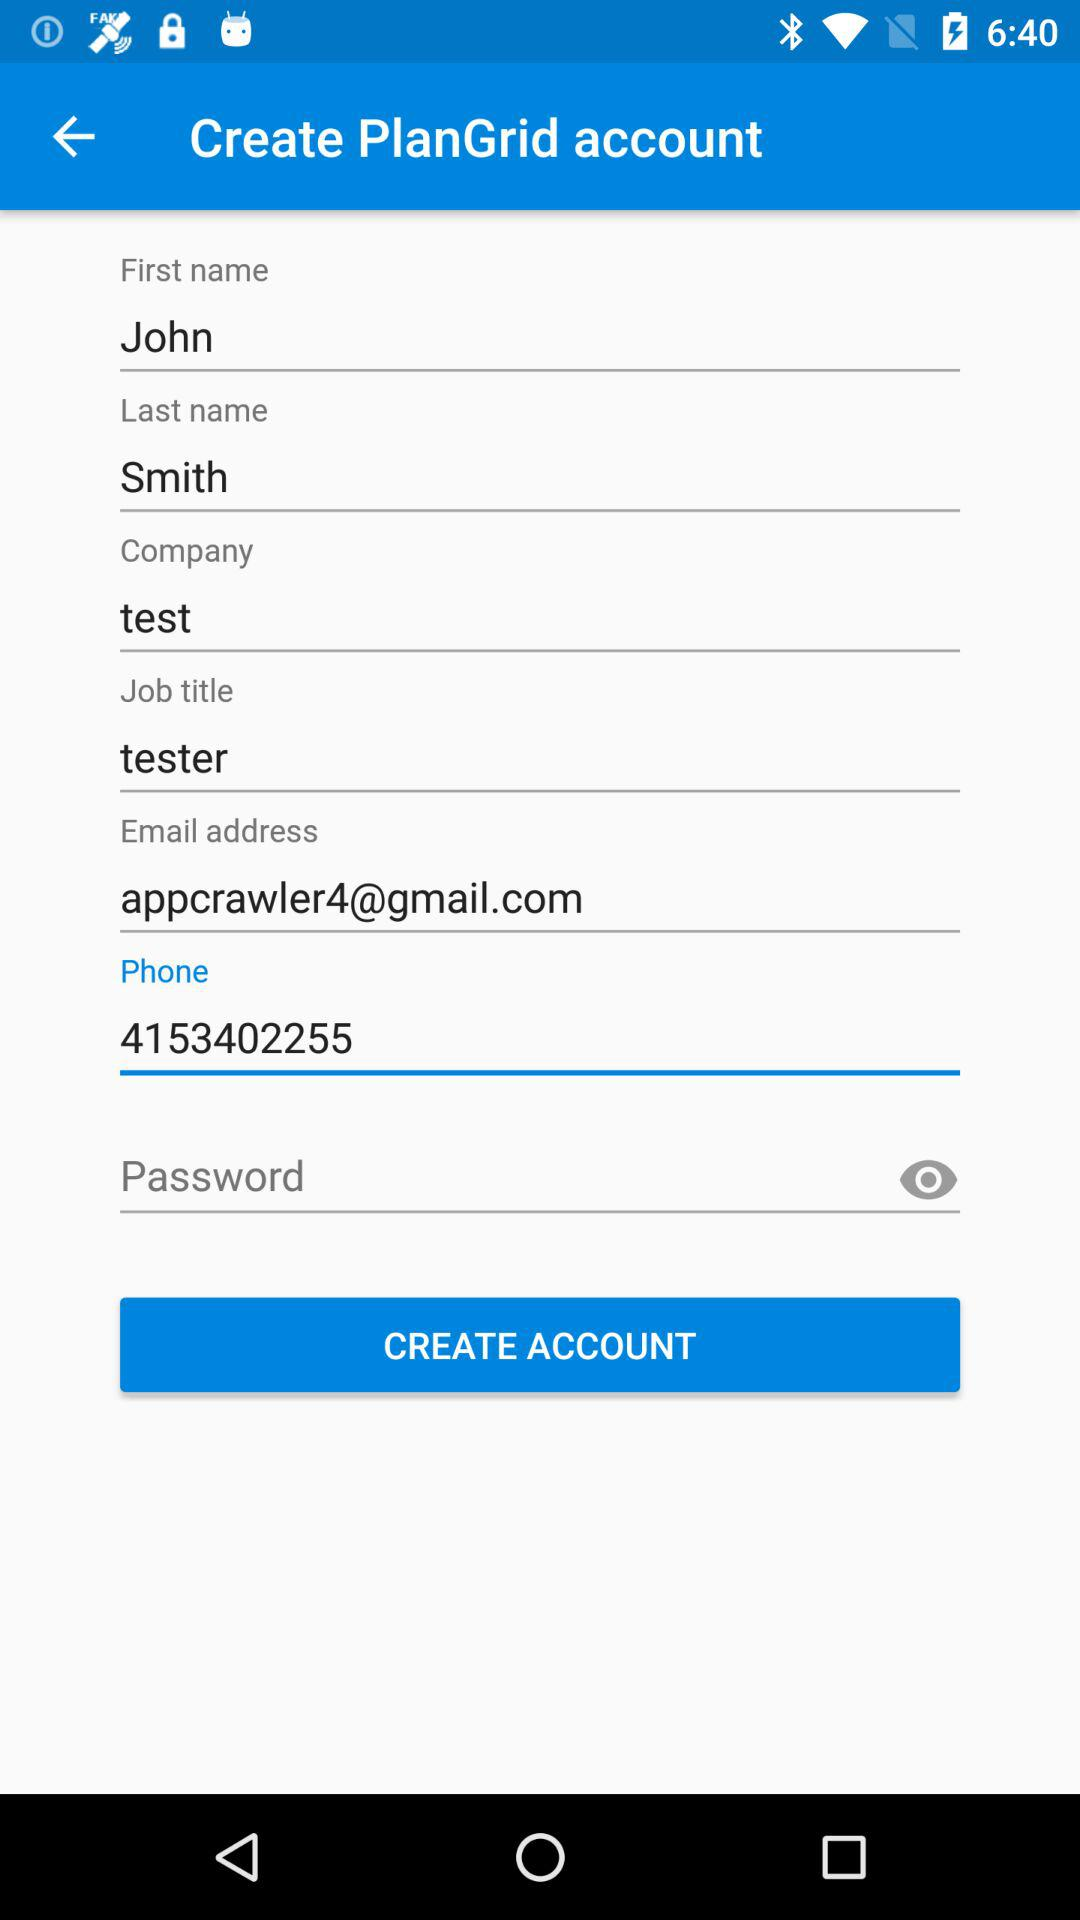What is the contact information? The contact information includes appcrawler4@gmail.com and 4153402255. 